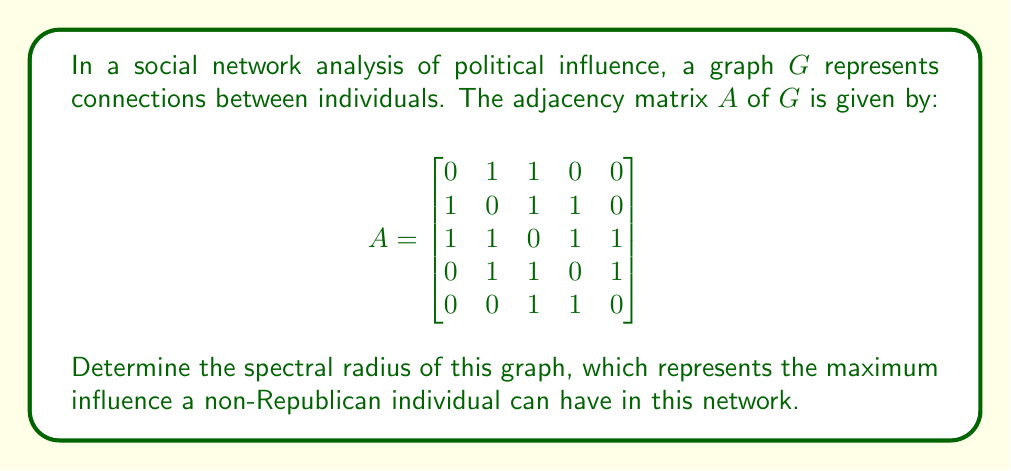Help me with this question. To find the spectral radius of the graph, we need to follow these steps:

1) The spectral radius is the largest absolute eigenvalue of the adjacency matrix $A$.

2) To find the eigenvalues, we need to solve the characteristic equation:
   $\det(A - \lambda I) = 0$

3) Expanding this determinant:
   $$\begin{vmatrix}
   -\lambda & 1 & 1 & 0 & 0 \\
   1 & -\lambda & 1 & 1 & 0 \\
   1 & 1 & -\lambda & 1 & 1 \\
   0 & 1 & 1 & -\lambda & 1 \\
   0 & 0 & 1 & 1 & -\lambda
   \end{vmatrix} = 0$$

4) This expands to the characteristic polynomial:
   $\lambda^5 - 7\lambda^3 - 4\lambda^2 + 3\lambda + 1 = 0$

5) While this polynomial is difficult to solve analytically, we can use numerical methods to approximate the roots.

6) Using a numerical solver, we find that the roots (eigenvalues) are approximately:
   $\lambda_1 \approx 2.4812$
   $\lambda_2 \approx -1.7321$
   $\lambda_3 \approx 0.8177$
   $\lambda_4 \approx -0.5858$
   $\lambda_5 \approx 0.0190$

7) The spectral radius is the largest absolute value among these eigenvalues, which is $\lambda_1 \approx 2.4812$.

This value represents the maximum influence a non-Republican individual can have in this network, as it corresponds to the dominant eigenvector of the adjacency matrix.
Answer: $2.4812$ (approximately) 